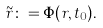Convert formula to latex. <formula><loc_0><loc_0><loc_500><loc_500>\tilde { r } \colon = \Phi ( r , t _ { 0 } ) .</formula> 